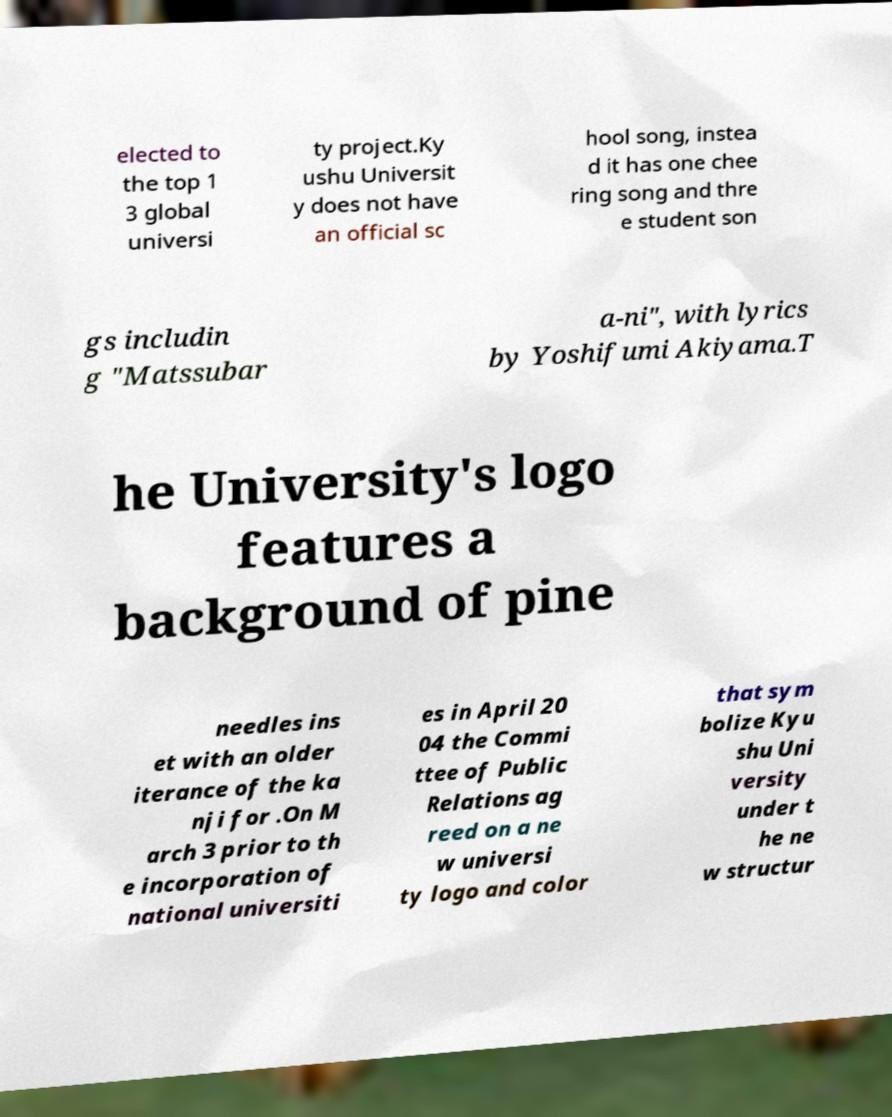Could you extract and type out the text from this image? elected to the top 1 3 global universi ty project.Ky ushu Universit y does not have an official sc hool song, instea d it has one chee ring song and thre e student son gs includin g "Matssubar a-ni", with lyrics by Yoshifumi Akiyama.T he University's logo features a background of pine needles ins et with an older iterance of the ka nji for .On M arch 3 prior to th e incorporation of national universiti es in April 20 04 the Commi ttee of Public Relations ag reed on a ne w universi ty logo and color that sym bolize Kyu shu Uni versity under t he ne w structur 